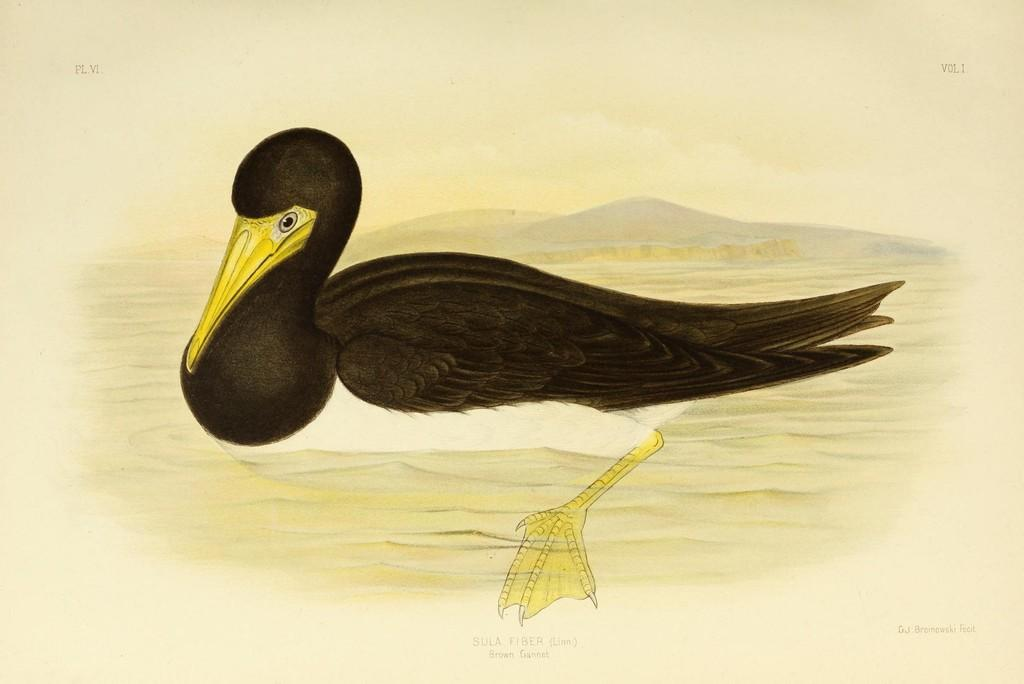What is featured on the poster in the image? There is a poster in the image, and it contains a picture of a bird. Can you describe the setting of the bird in the poster? The bird is depicted on the water in the poster. What type of humor can be seen in the bird's expression in the image? There is no indication of the bird's expression in the image, and therefore no humor can be observed. 